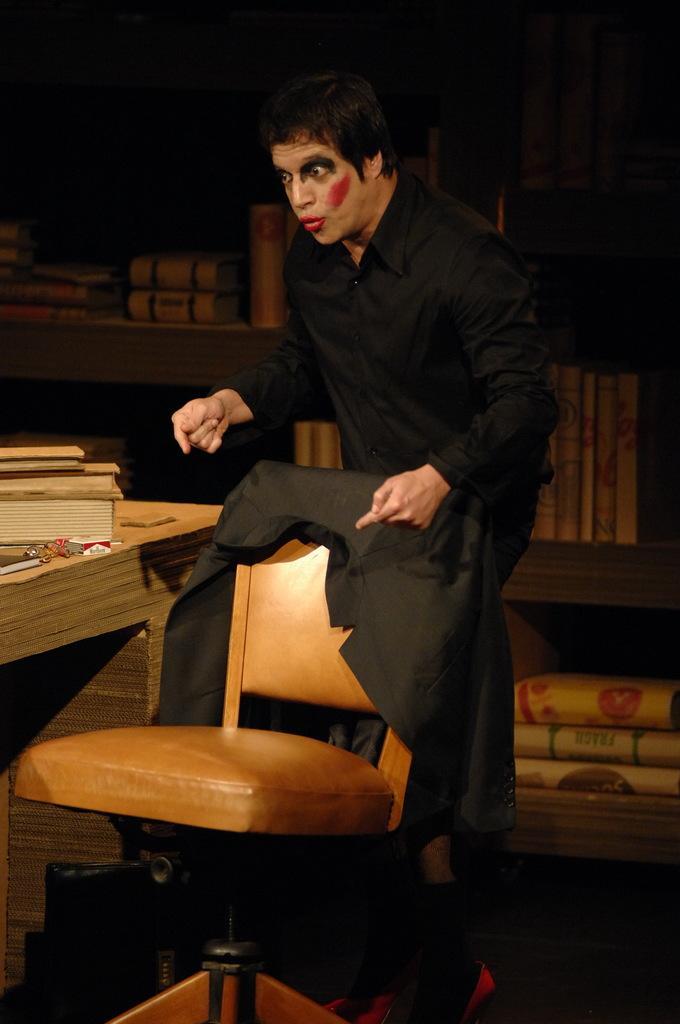In one or two sentences, can you explain what this image depicts? In the middle of the image a man is standing. In front of him there is a chair. Bottom left side of the image there is a table. On the table there are some books. Right side of the image there is a shelf. 